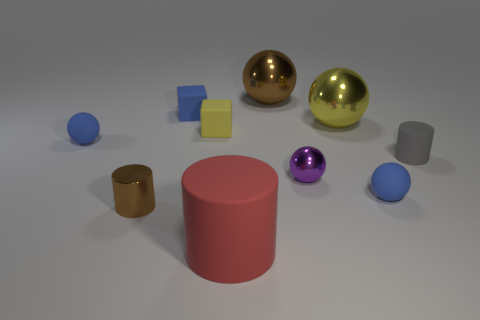Subtract all big metal balls. How many balls are left? 3 Subtract all cubes. How many objects are left? 8 Subtract 1 spheres. How many spheres are left? 4 Subtract all blue balls. Subtract all purple cylinders. How many balls are left? 3 Subtract all gray cubes. How many cyan balls are left? 0 Subtract all small brown metallic objects. Subtract all brown things. How many objects are left? 7 Add 3 cubes. How many cubes are left? 5 Add 6 large yellow metal balls. How many large yellow metal balls exist? 7 Subtract all brown spheres. How many spheres are left? 4 Subtract 0 blue cylinders. How many objects are left? 10 